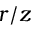Convert formula to latex. <formula><loc_0><loc_0><loc_500><loc_500>r / z</formula> 